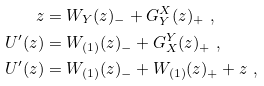Convert formula to latex. <formula><loc_0><loc_0><loc_500><loc_500>z & = W _ { Y } ( z ) _ { - } + G _ { Y } ^ { X } ( z ) _ { + } \ , \\ U ^ { \prime } ( z ) & = W _ { ( 1 ) } ( z ) _ { - } + G _ { X } ^ { Y } ( z ) _ { + } \ , \\ U ^ { \prime } ( z ) & = W _ { ( 1 ) } ( z ) _ { - } + W _ { ( 1 ) } ( z ) _ { + } + z \ ,</formula> 